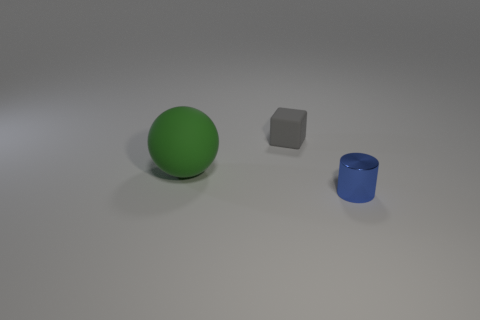If I were to arrange these objects by size, starting with the smallest, how would they be ordered? Starting with the smallest, the order would be the blue cylinder, followed by the gray block, and finally the largest, the green sphere. 